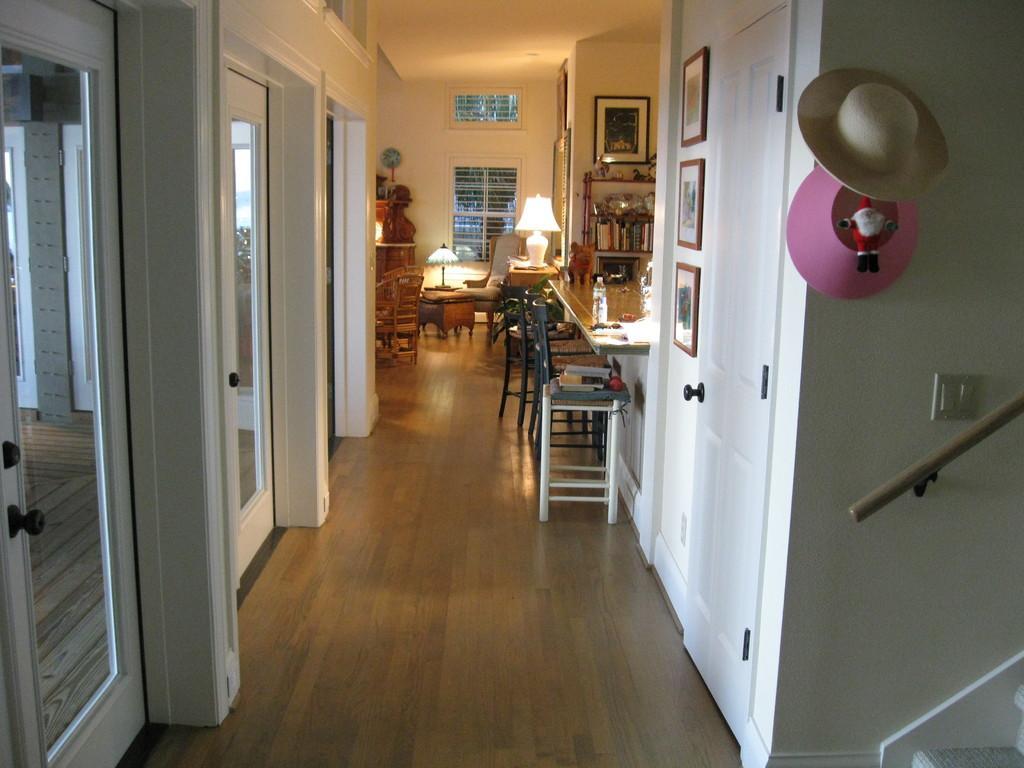How would you summarize this image in a sentence or two? In this picture I can see there is a house and there are some table, sofa, chairs here and in the backdrop there are some lamps and hats here. 